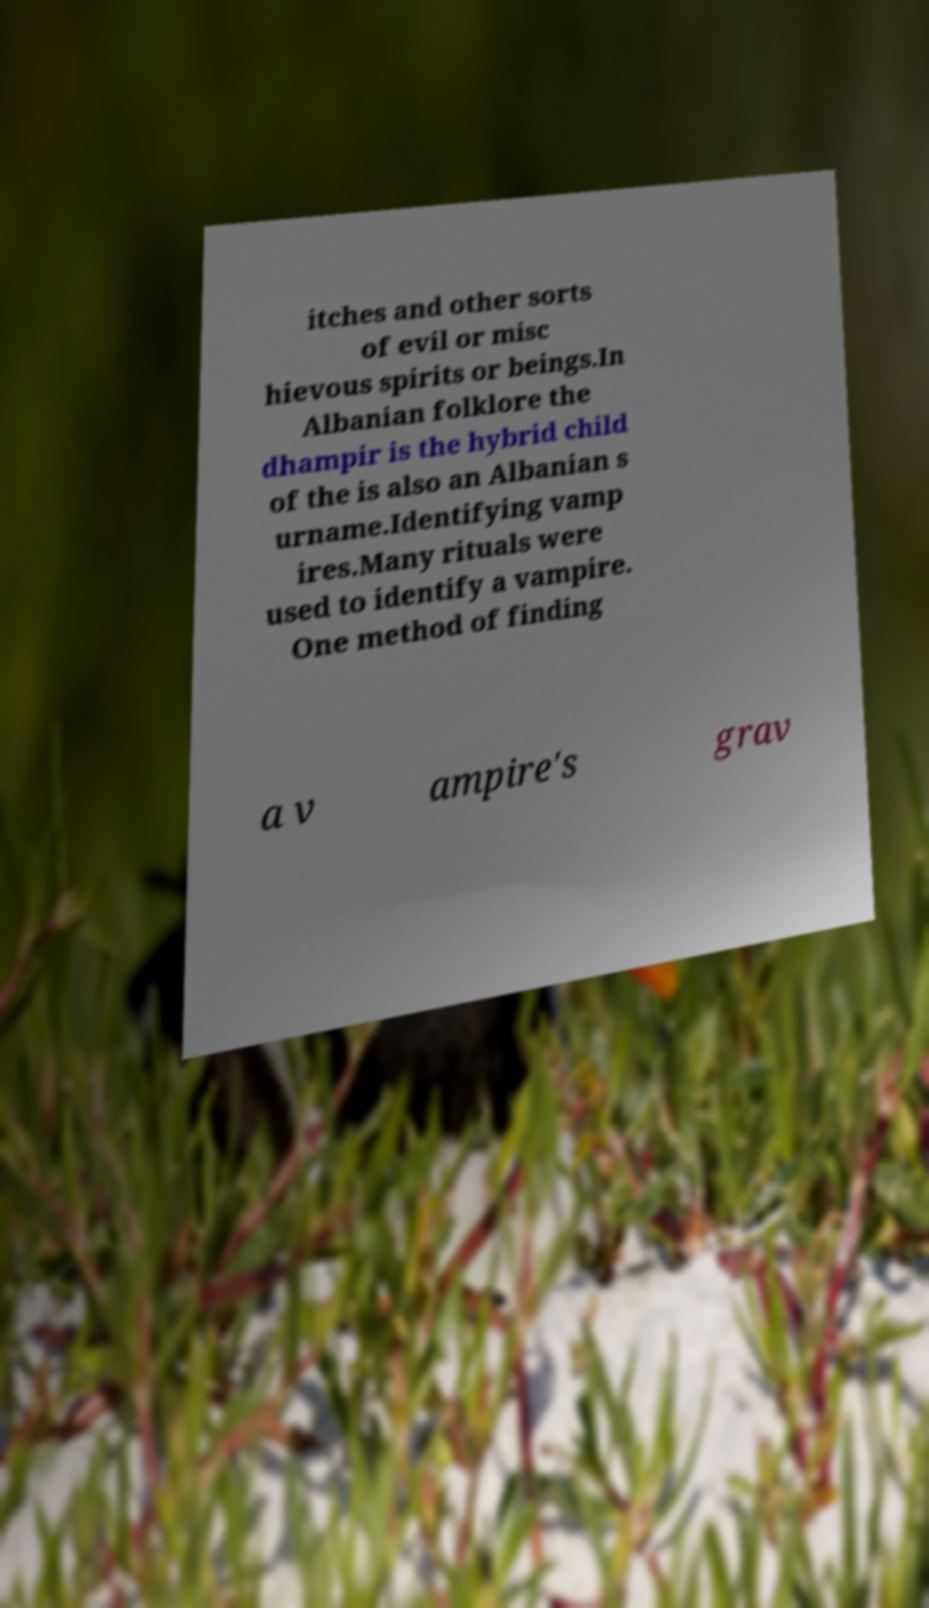Could you extract and type out the text from this image? itches and other sorts of evil or misc hievous spirits or beings.In Albanian folklore the dhampir is the hybrid child of the is also an Albanian s urname.Identifying vamp ires.Many rituals were used to identify a vampire. One method of finding a v ampire's grav 